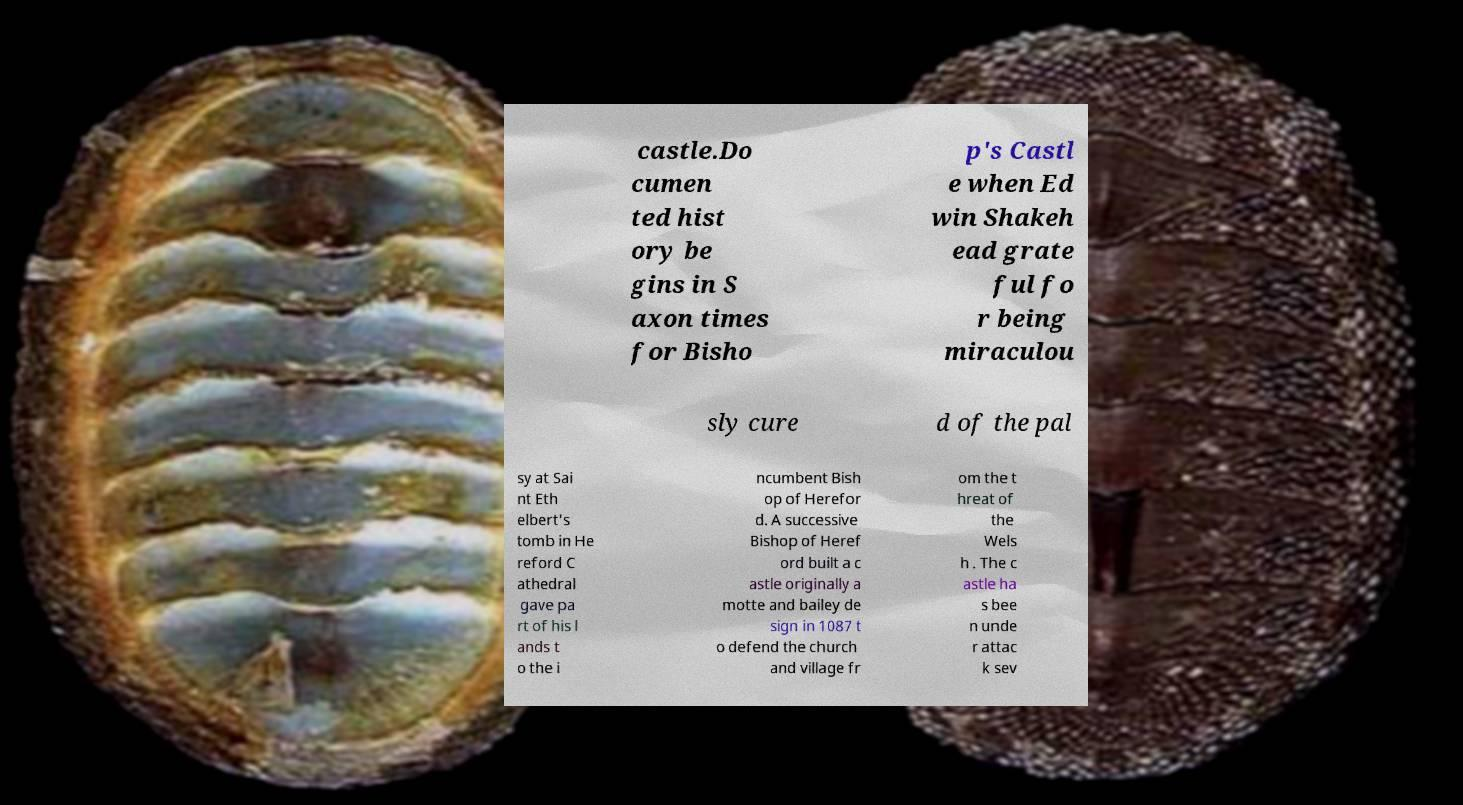Please read and relay the text visible in this image. What does it say? castle.Do cumen ted hist ory be gins in S axon times for Bisho p's Castl e when Ed win Shakeh ead grate ful fo r being miraculou sly cure d of the pal sy at Sai nt Eth elbert's tomb in He reford C athedral gave pa rt of his l ands t o the i ncumbent Bish op of Herefor d. A successive Bishop of Heref ord built a c astle originally a motte and bailey de sign in 1087 t o defend the church and village fr om the t hreat of the Wels h . The c astle ha s bee n unde r attac k sev 